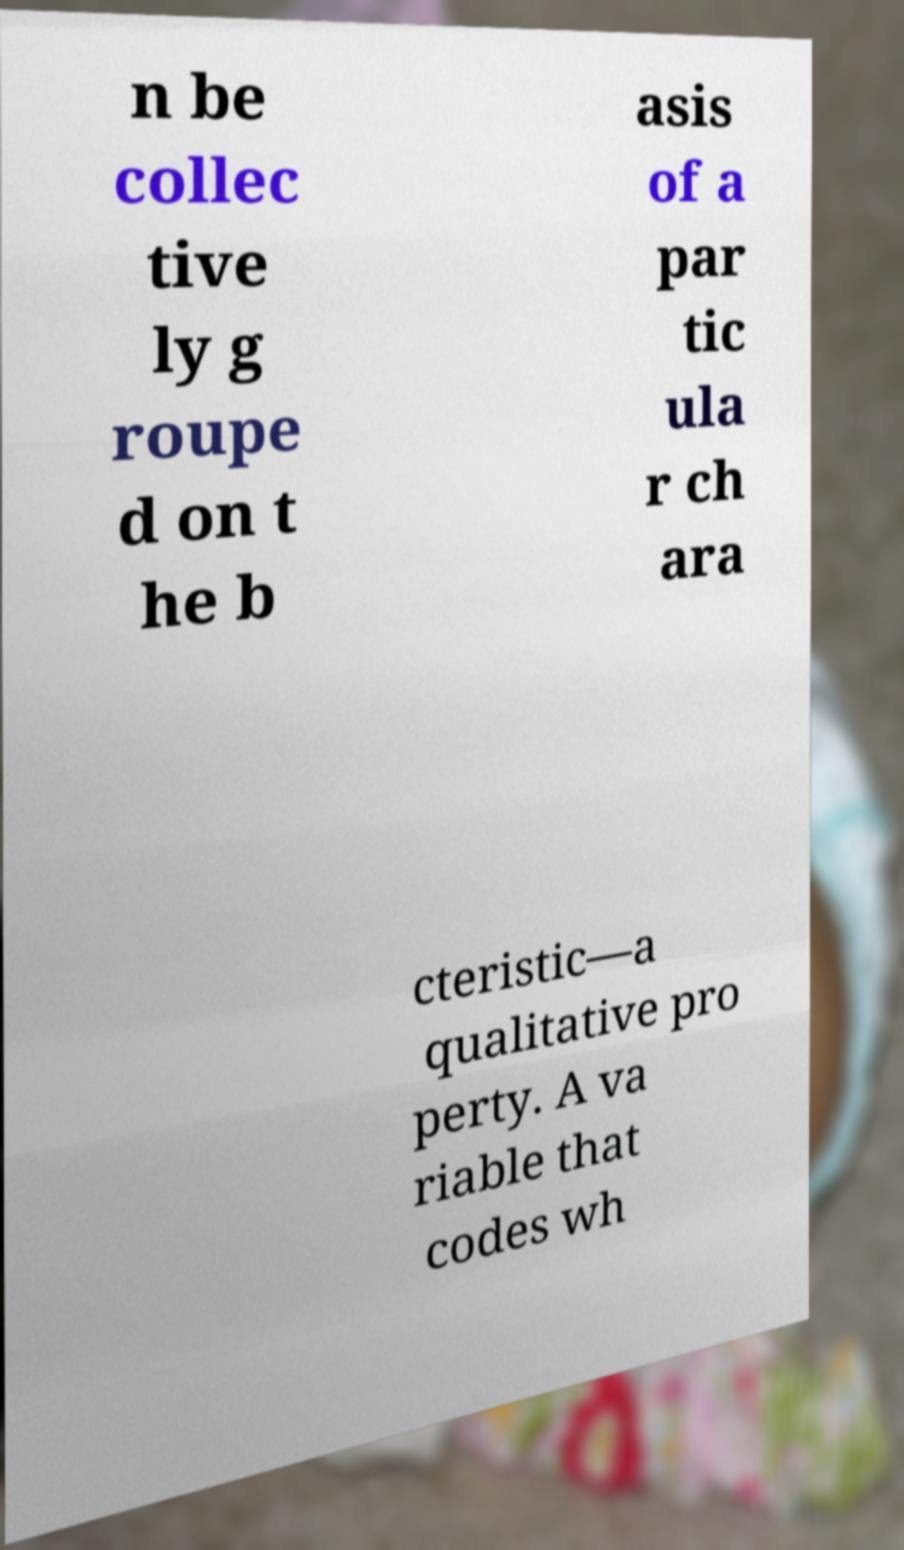Please identify and transcribe the text found in this image. n be collec tive ly g roupe d on t he b asis of a par tic ula r ch ara cteristic—a qualitative pro perty. A va riable that codes wh 